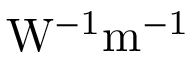<formula> <loc_0><loc_0><loc_500><loc_500>W ^ { - 1 } m ^ { - 1 }</formula> 